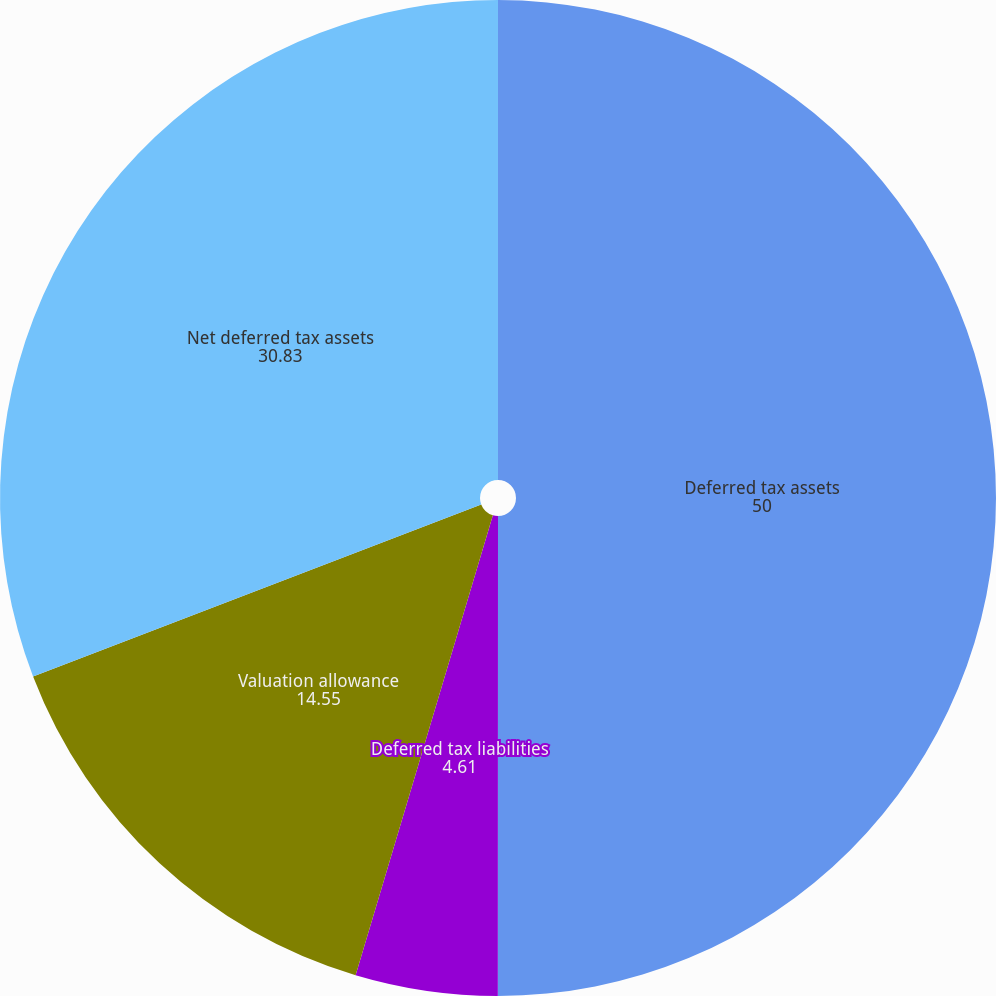<chart> <loc_0><loc_0><loc_500><loc_500><pie_chart><fcel>Deferred tax assets<fcel>Deferred tax liabilities<fcel>Valuation allowance<fcel>Net deferred tax assets<nl><fcel>50.0%<fcel>4.61%<fcel>14.55%<fcel>30.83%<nl></chart> 